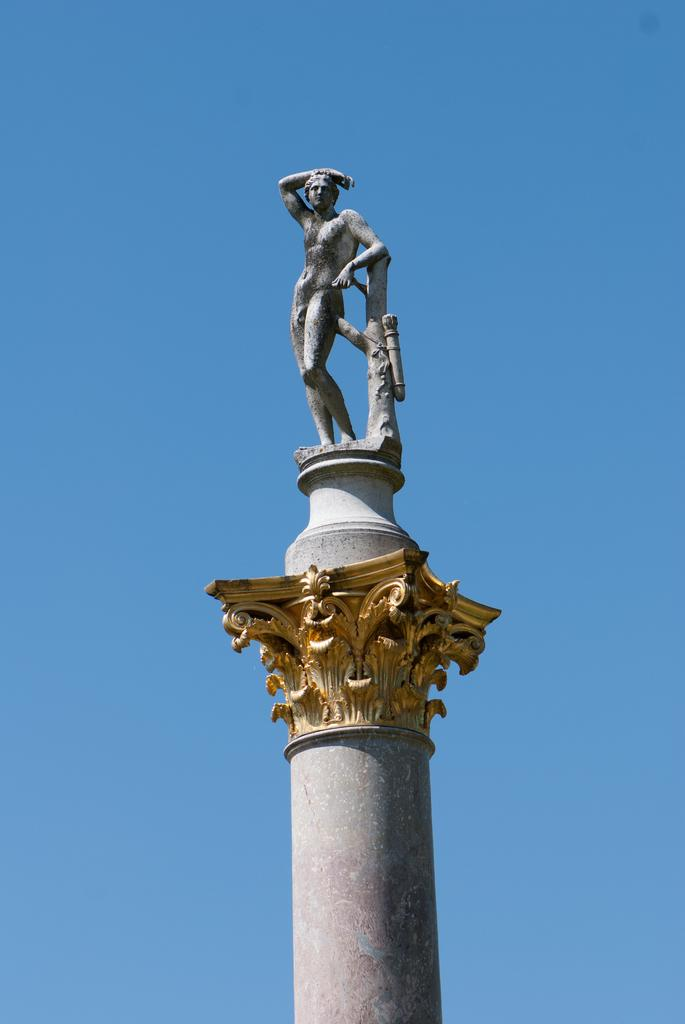What is the main subject in the middle of the image? There is a statue in the middle of the image. What can be seen at the top of the image? The sky is visible at the top of the image. What type of butter is being sold in the shop near the statue? There is no shop or butter present in the image; it only features a statue and the sky. 